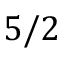Convert formula to latex. <formula><loc_0><loc_0><loc_500><loc_500>5 / 2</formula> 